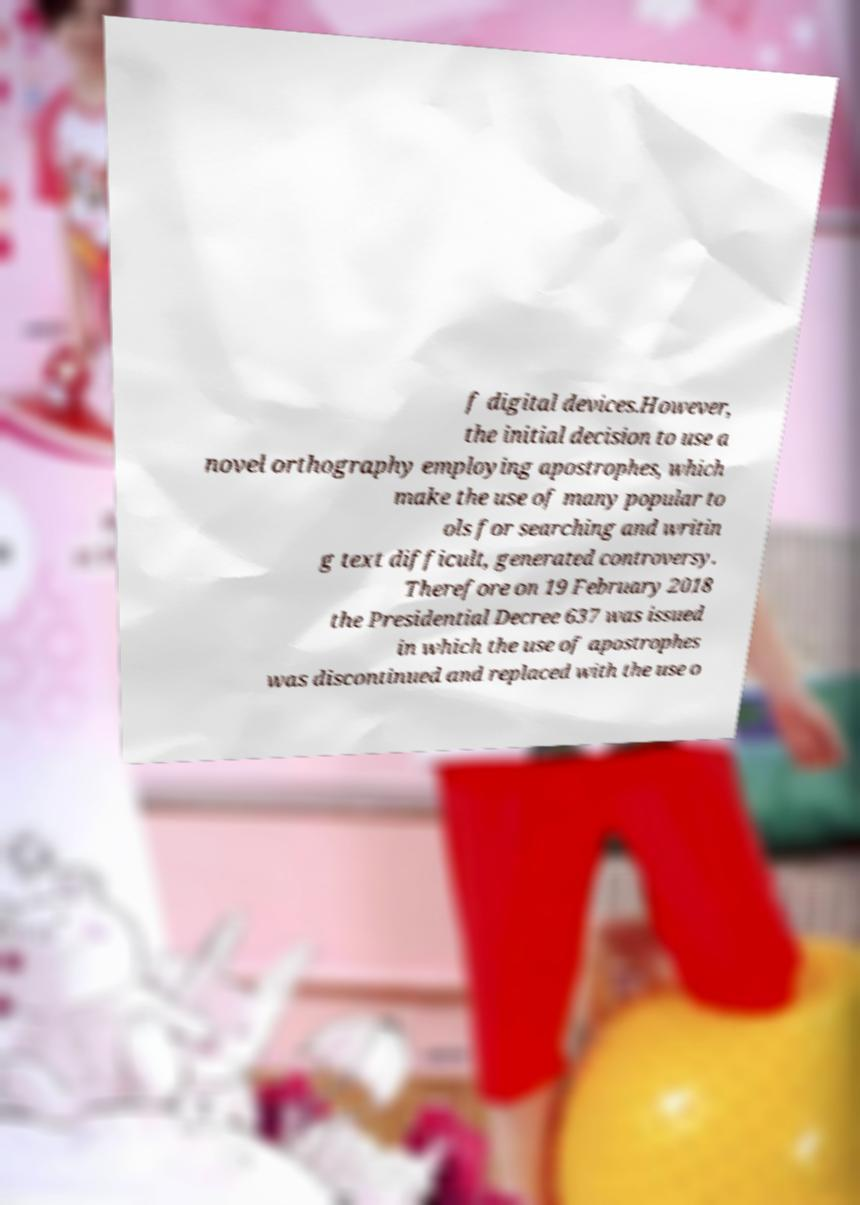I need the written content from this picture converted into text. Can you do that? f digital devices.However, the initial decision to use a novel orthography employing apostrophes, which make the use of many popular to ols for searching and writin g text difficult, generated controversy. Therefore on 19 February 2018 the Presidential Decree 637 was issued in which the use of apostrophes was discontinued and replaced with the use o 